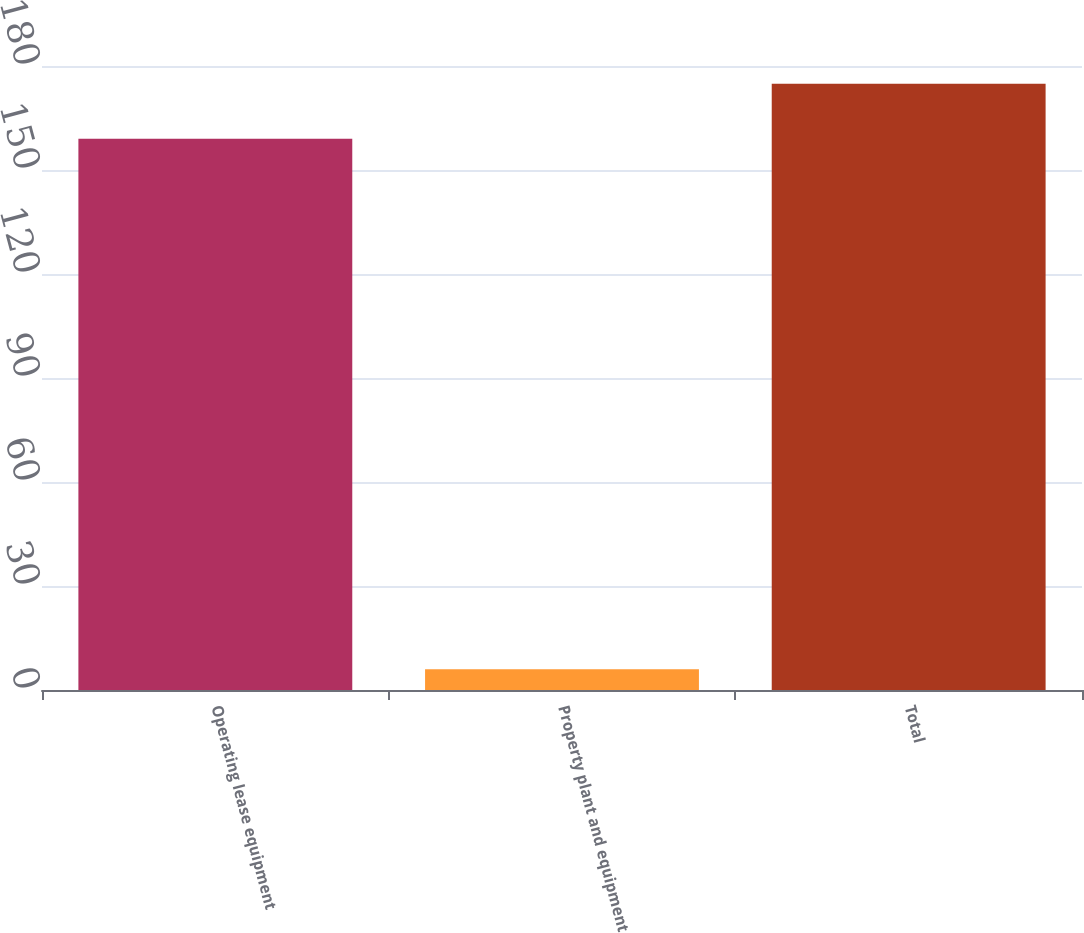Convert chart to OTSL. <chart><loc_0><loc_0><loc_500><loc_500><bar_chart><fcel>Operating lease equipment<fcel>Property plant and equipment<fcel>Total<nl><fcel>159<fcel>6<fcel>174.9<nl></chart> 